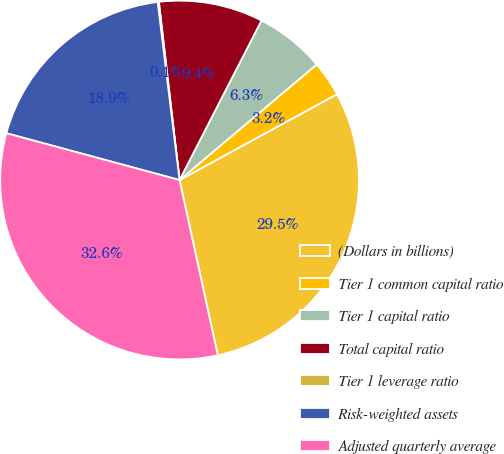<chart> <loc_0><loc_0><loc_500><loc_500><pie_chart><fcel>(Dollars in billions)<fcel>Tier 1 common capital ratio<fcel>Tier 1 capital ratio<fcel>Total capital ratio<fcel>Tier 1 leverage ratio<fcel>Risk-weighted assets<fcel>Adjusted quarterly average<nl><fcel>29.53%<fcel>3.2%<fcel>6.3%<fcel>9.39%<fcel>0.11%<fcel>18.85%<fcel>32.62%<nl></chart> 